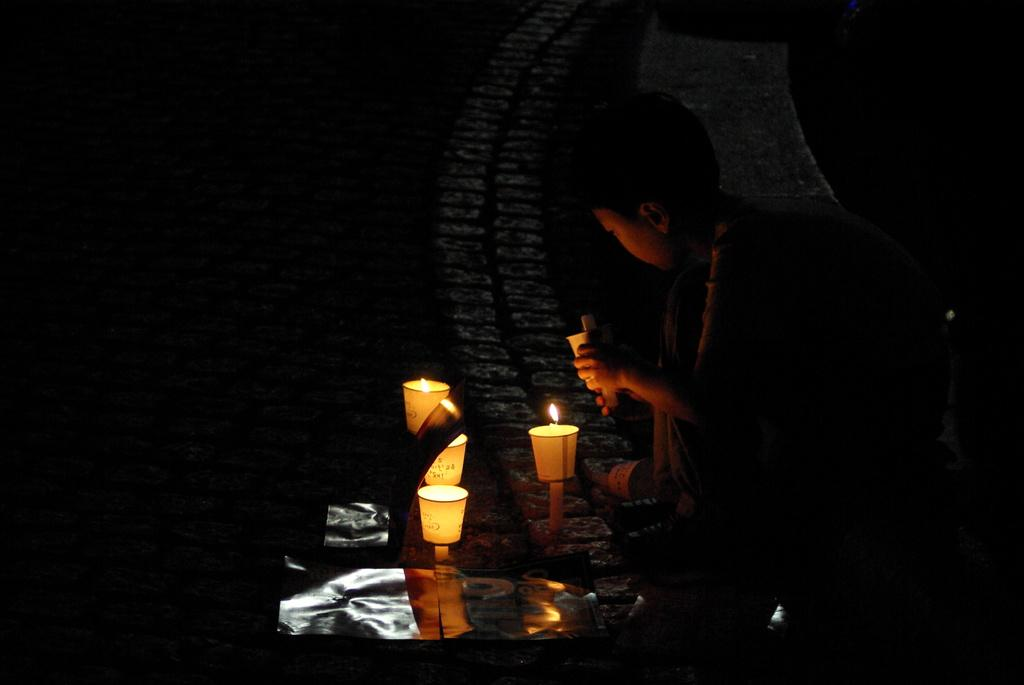What is the main subject of the image? The main subject of the image is a boy. What is the boy doing in the image? The boy is sitting on the road. What objects are in front of the boy? There are candles in front of the boy. How many dogs are present in the image? There are no dogs present in the image. What type of peace symbol can be seen in the image? There is no peace symbol present in the image. 